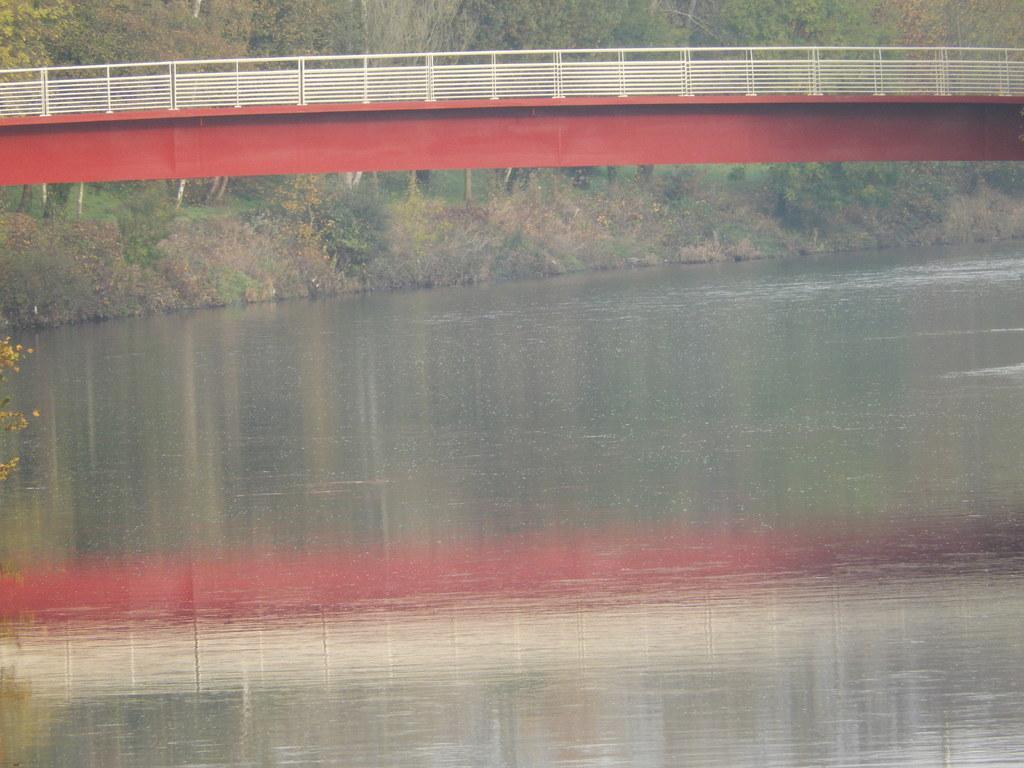In one or two sentences, can you explain what this image depicts? In the background we can see the trees. In this picture we can see a bridge and railing. At the bottom portion of the picture we can see the water. On the left side of the picture leaves are visible. 